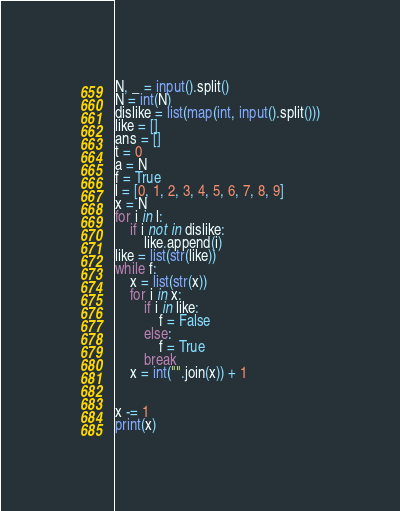<code> <loc_0><loc_0><loc_500><loc_500><_Python_>N, _ = input().split()
N = int(N)
dislike = list(map(int, input().split()))
like = []
ans = []
t = 0
a = N
f = True
l = [0, 1, 2, 3, 4, 5, 6, 7, 8, 9]
x = N
for i in l:
    if i not in dislike:
        like.append(i)
like = list(str(like))
while f:
    x = list(str(x))
    for i in x:
        if i in like:
            f = False
        else:
            f = True
        break
    x = int("".join(x)) + 1


x -= 1
print(x)</code> 